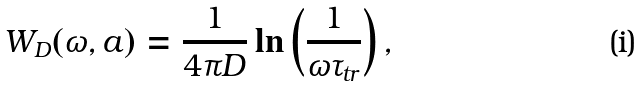Convert formula to latex. <formula><loc_0><loc_0><loc_500><loc_500>W _ { D } ( \omega , a ) = \frac { 1 } { 4 \pi D } \ln \left ( \frac { 1 } { \omega \tau _ { t r } } \right ) ,</formula> 